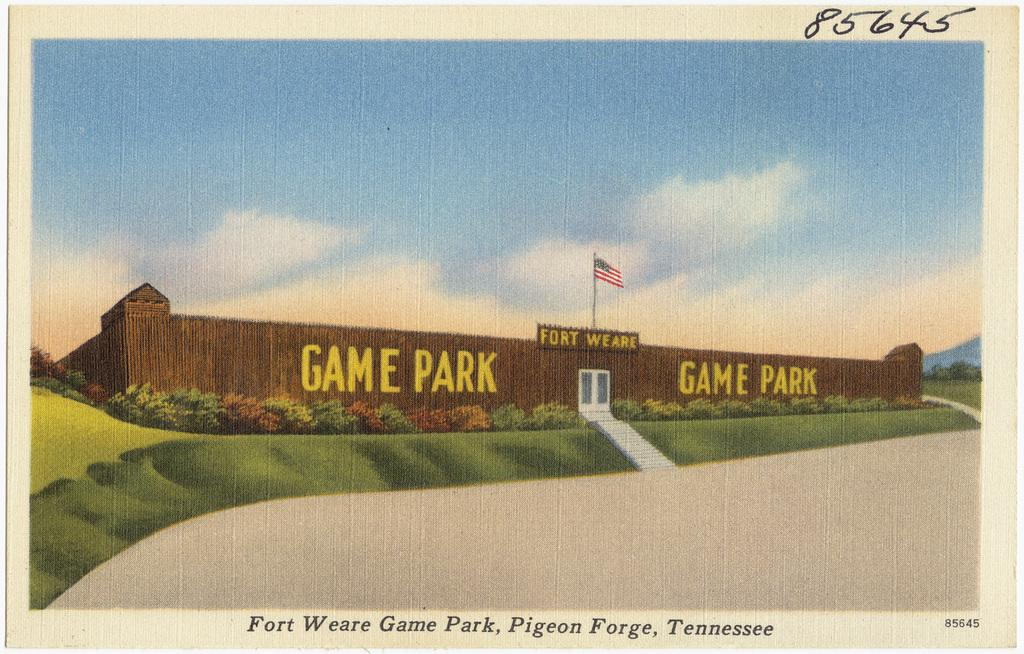<image>
Present a compact description of the photo's key features. A card featuring a drawing of the Fort Weare Game Park 